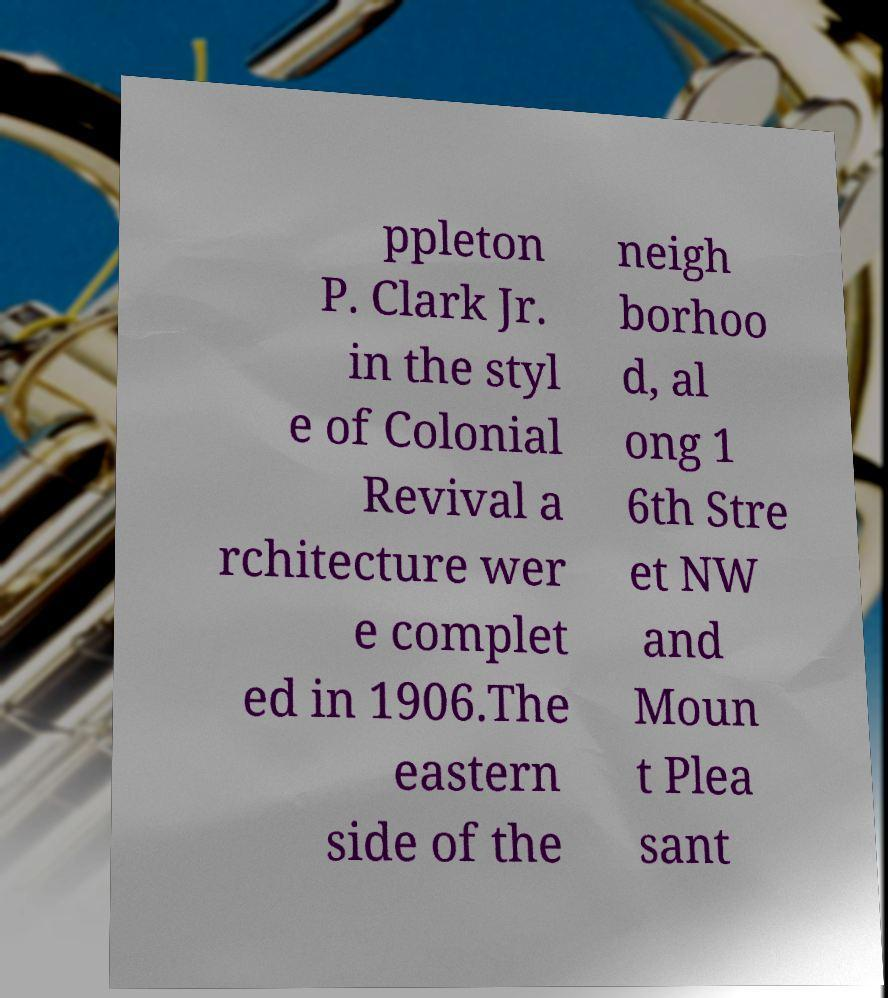Can you accurately transcribe the text from the provided image for me? ppleton P. Clark Jr. in the styl e of Colonial Revival a rchitecture wer e complet ed in 1906.The eastern side of the neigh borhoo d, al ong 1 6th Stre et NW and Moun t Plea sant 